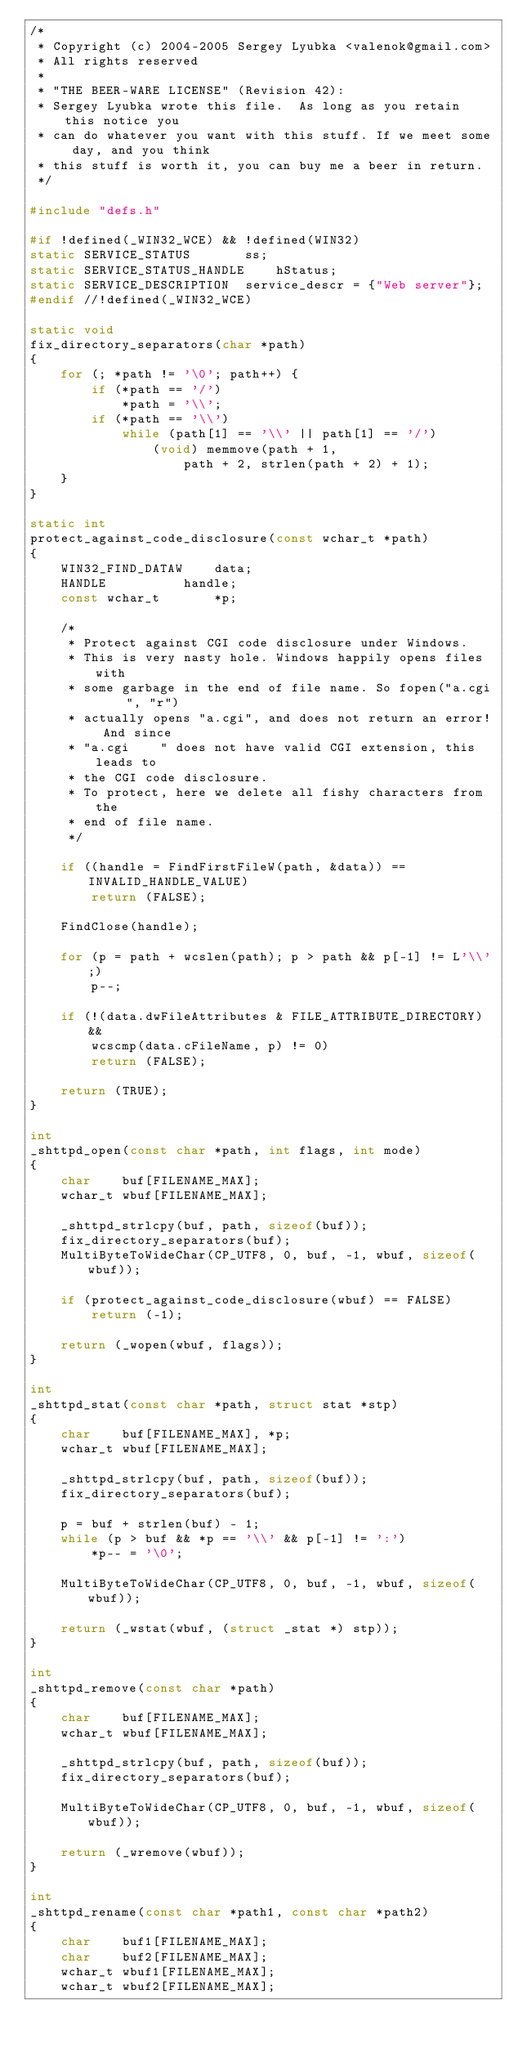<code> <loc_0><loc_0><loc_500><loc_500><_C_>/*
 * Copyright (c) 2004-2005 Sergey Lyubka <valenok@gmail.com>
 * All rights reserved
 *
 * "THE BEER-WARE LICENSE" (Revision 42):
 * Sergey Lyubka wrote this file.  As long as you retain this notice you
 * can do whatever you want with this stuff. If we meet some day, and you think
 * this stuff is worth it, you can buy me a beer in return.
 */

#include "defs.h"

#if !defined(_WIN32_WCE) && !defined(WIN32)
static SERVICE_STATUS		ss; 
static SERVICE_STATUS_HANDLE	hStatus; 
static SERVICE_DESCRIPTION	service_descr = {"Web server"};
#endif //!defined(_WIN32_WCE)

static void
fix_directory_separators(char *path)
{
	for (; *path != '\0'; path++) {
		if (*path == '/')
			*path = '\\';
		if (*path == '\\')
			while (path[1] == '\\' || path[1] == '/') 
				(void) memmove(path + 1,
				    path + 2, strlen(path + 2) + 1);
	}
}

static int
protect_against_code_disclosure(const wchar_t *path)
{
	WIN32_FIND_DATAW	data;
	HANDLE			handle;
	const wchar_t		*p;

	/*
	 * Protect against CGI code disclosure under Windows.
	 * This is very nasty hole. Windows happily opens files with
	 * some garbage in the end of file name. So fopen("a.cgi    ", "r")
	 * actually opens "a.cgi", and does not return an error! And since
	 * "a.cgi    " does not have valid CGI extension, this leads to
	 * the CGI code disclosure.
	 * To protect, here we delete all fishy characters from the
	 * end of file name.
	 */

	if ((handle = FindFirstFileW(path, &data)) == INVALID_HANDLE_VALUE)
		return (FALSE);

	FindClose(handle);

	for (p = path + wcslen(path); p > path && p[-1] != L'\\';)
		p--;
	
	if (!(data.dwFileAttributes & FILE_ATTRIBUTE_DIRECTORY) &&
	    wcscmp(data.cFileName, p) != 0)
		return (FALSE);

	return (TRUE);
}

int
_shttpd_open(const char *path, int flags, int mode)
{
	char	buf[FILENAME_MAX];
	wchar_t	wbuf[FILENAME_MAX];

	_shttpd_strlcpy(buf, path, sizeof(buf));
	fix_directory_separators(buf);
	MultiByteToWideChar(CP_UTF8, 0, buf, -1, wbuf, sizeof(wbuf));

	if (protect_against_code_disclosure(wbuf) == FALSE)
		return (-1);

	return (_wopen(wbuf, flags));
}

int
_shttpd_stat(const char *path, struct stat *stp)
{
	char	buf[FILENAME_MAX], *p;
	wchar_t	wbuf[FILENAME_MAX];

	_shttpd_strlcpy(buf, path, sizeof(buf));
	fix_directory_separators(buf);

	p = buf + strlen(buf) - 1;
	while (p > buf && *p == '\\' && p[-1] != ':')
		*p-- = '\0';

	MultiByteToWideChar(CP_UTF8, 0, buf, -1, wbuf, sizeof(wbuf));

	return (_wstat(wbuf, (struct _stat *) stp));
}

int
_shttpd_remove(const char *path)
{
	char	buf[FILENAME_MAX];
	wchar_t	wbuf[FILENAME_MAX];

	_shttpd_strlcpy(buf, path, sizeof(buf));
	fix_directory_separators(buf);

	MultiByteToWideChar(CP_UTF8, 0, buf, -1, wbuf, sizeof(wbuf));

	return (_wremove(wbuf));
}

int
_shttpd_rename(const char *path1, const char *path2)
{
	char	buf1[FILENAME_MAX];
	char	buf2[FILENAME_MAX];
	wchar_t	wbuf1[FILENAME_MAX];
	wchar_t	wbuf2[FILENAME_MAX];
</code> 